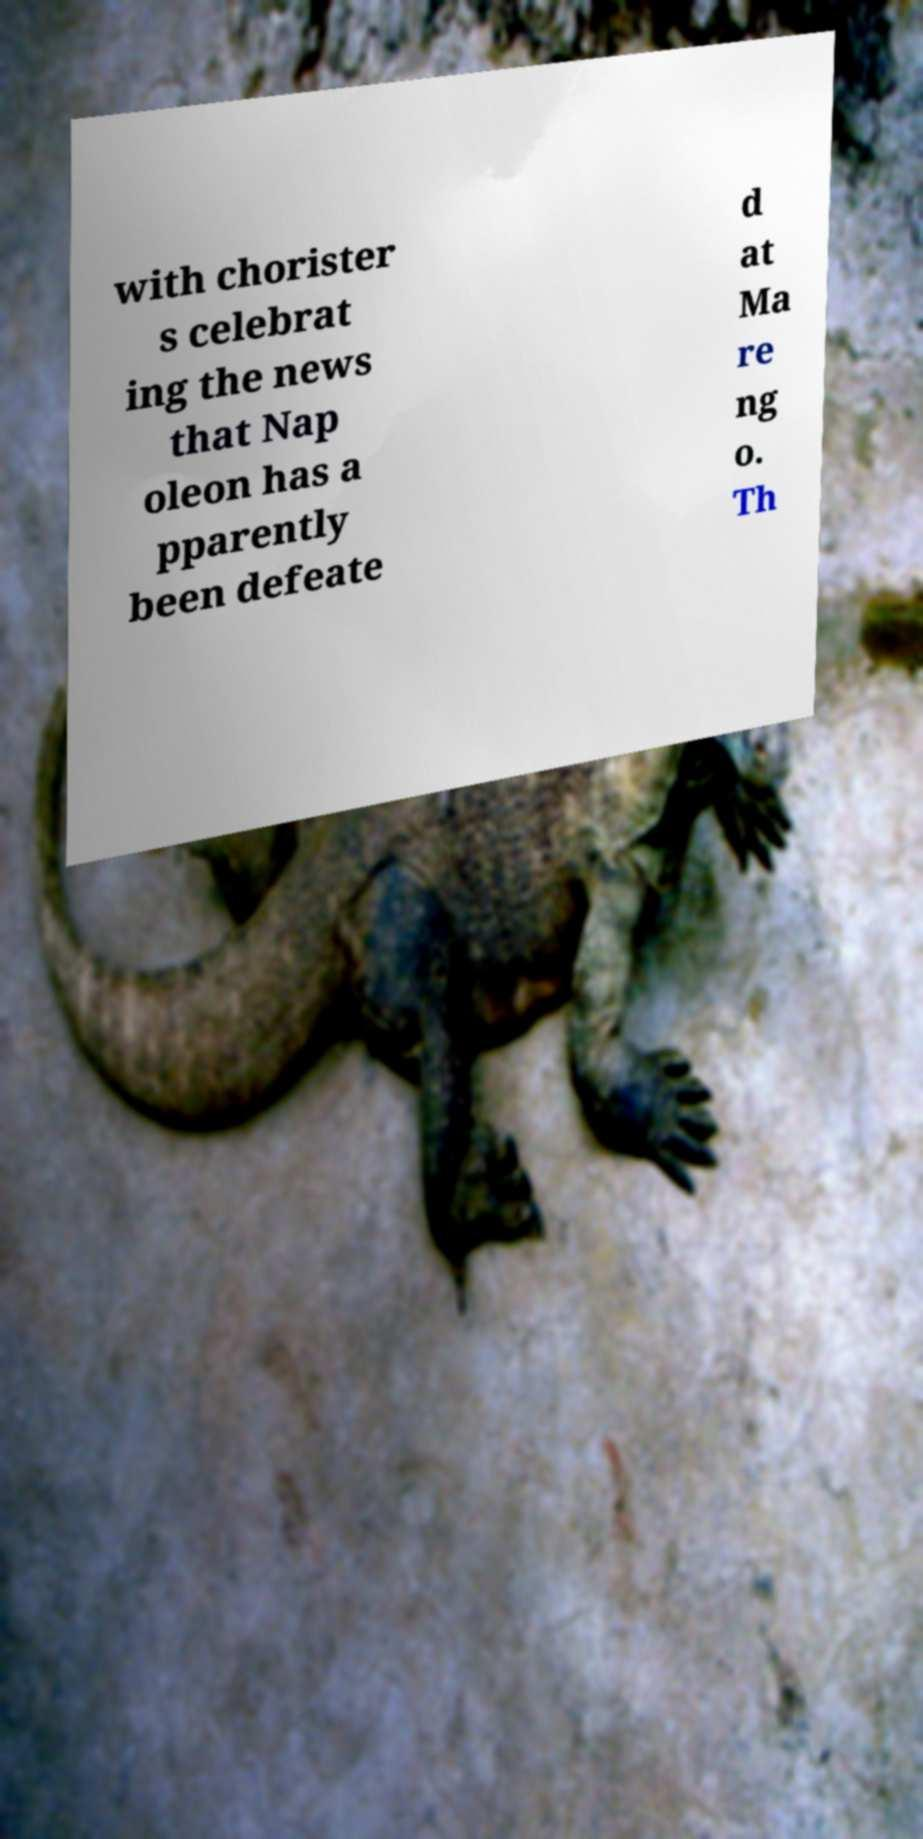For documentation purposes, I need the text within this image transcribed. Could you provide that? with chorister s celebrat ing the news that Nap oleon has a pparently been defeate d at Ma re ng o. Th 